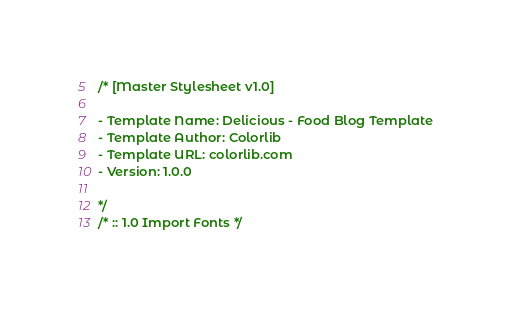<code> <loc_0><loc_0><loc_500><loc_500><_CSS_>/* [Master Stylesheet v1.0]

- Template Name: Delicious - Food Blog Template
- Template Author: Colorlib
- Template URL: colorlib.com
- Version: 1.0.0

*/
/* :: 1.0 Import Fonts */</code> 